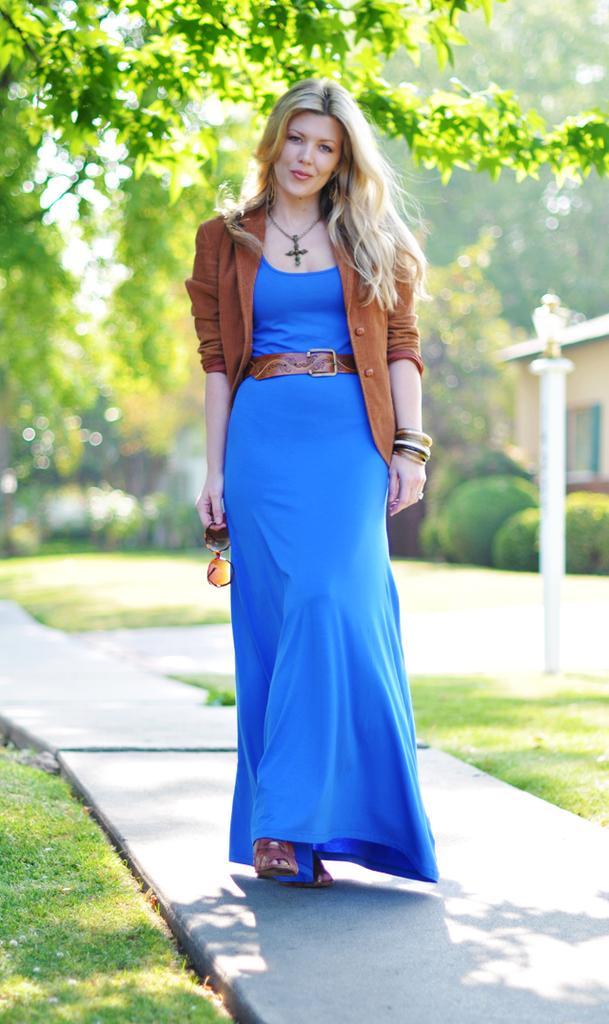Describe this image in one or two sentences. In this image I can see a path and on it I can see a woman is standing. I can see she is wearing a blue colour dress, a brown colour jacket, a belt, a necklace and I can see she is holding a shades. On the both sides of the path I can see grass. In the background I can see a pole, a light, a building, number of plants and number of trees. I can also see this image is little bit blurry. 